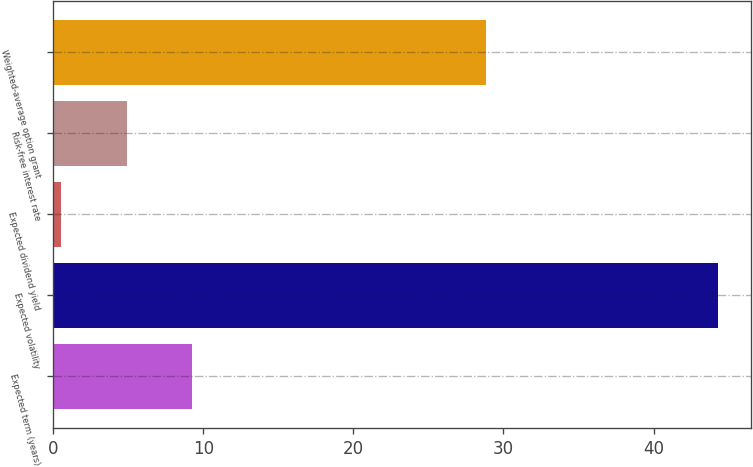<chart> <loc_0><loc_0><loc_500><loc_500><bar_chart><fcel>Expected term (years)<fcel>Expected volatility<fcel>Expected dividend yield<fcel>Risk-free interest rate<fcel>Weighted-average option grant<nl><fcel>9.28<fcel>44.3<fcel>0.52<fcel>4.9<fcel>28.84<nl></chart> 